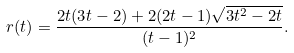Convert formula to latex. <formula><loc_0><loc_0><loc_500><loc_500>r ( t ) = \frac { 2 t ( 3 t - 2 ) + 2 ( 2 t - 1 ) \sqrt { 3 t ^ { 2 } - 2 t } } { ( t - 1 ) ^ { 2 } } .</formula> 